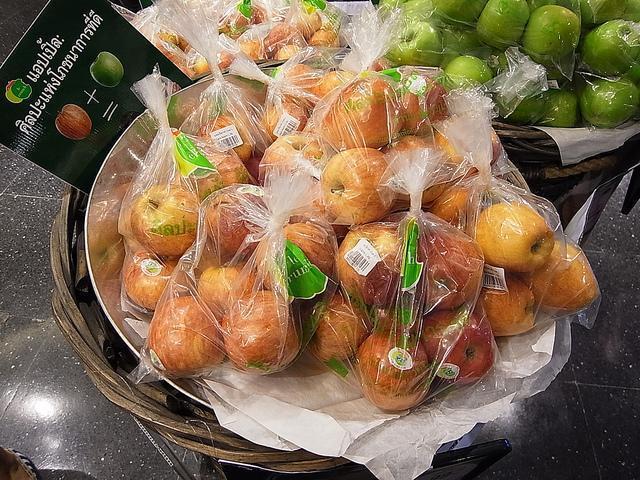What is the condition of these items?
Make your selection from the four choices given to correctly answer the question.
Options: Cooking, plated, wrapped, exposed. Wrapped. 